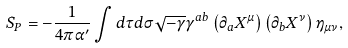Convert formula to latex. <formula><loc_0><loc_0><loc_500><loc_500>S _ { P } = - \frac { 1 } { 4 \pi \alpha ^ { \prime } } \int { d \tau d \sigma \sqrt { - \gamma } \gamma ^ { a b } \left ( { \partial _ { a } X ^ { \mu } } \right ) \left ( { \partial _ { b } X ^ { \nu } } \right ) \eta _ { \mu \nu } } ,</formula> 